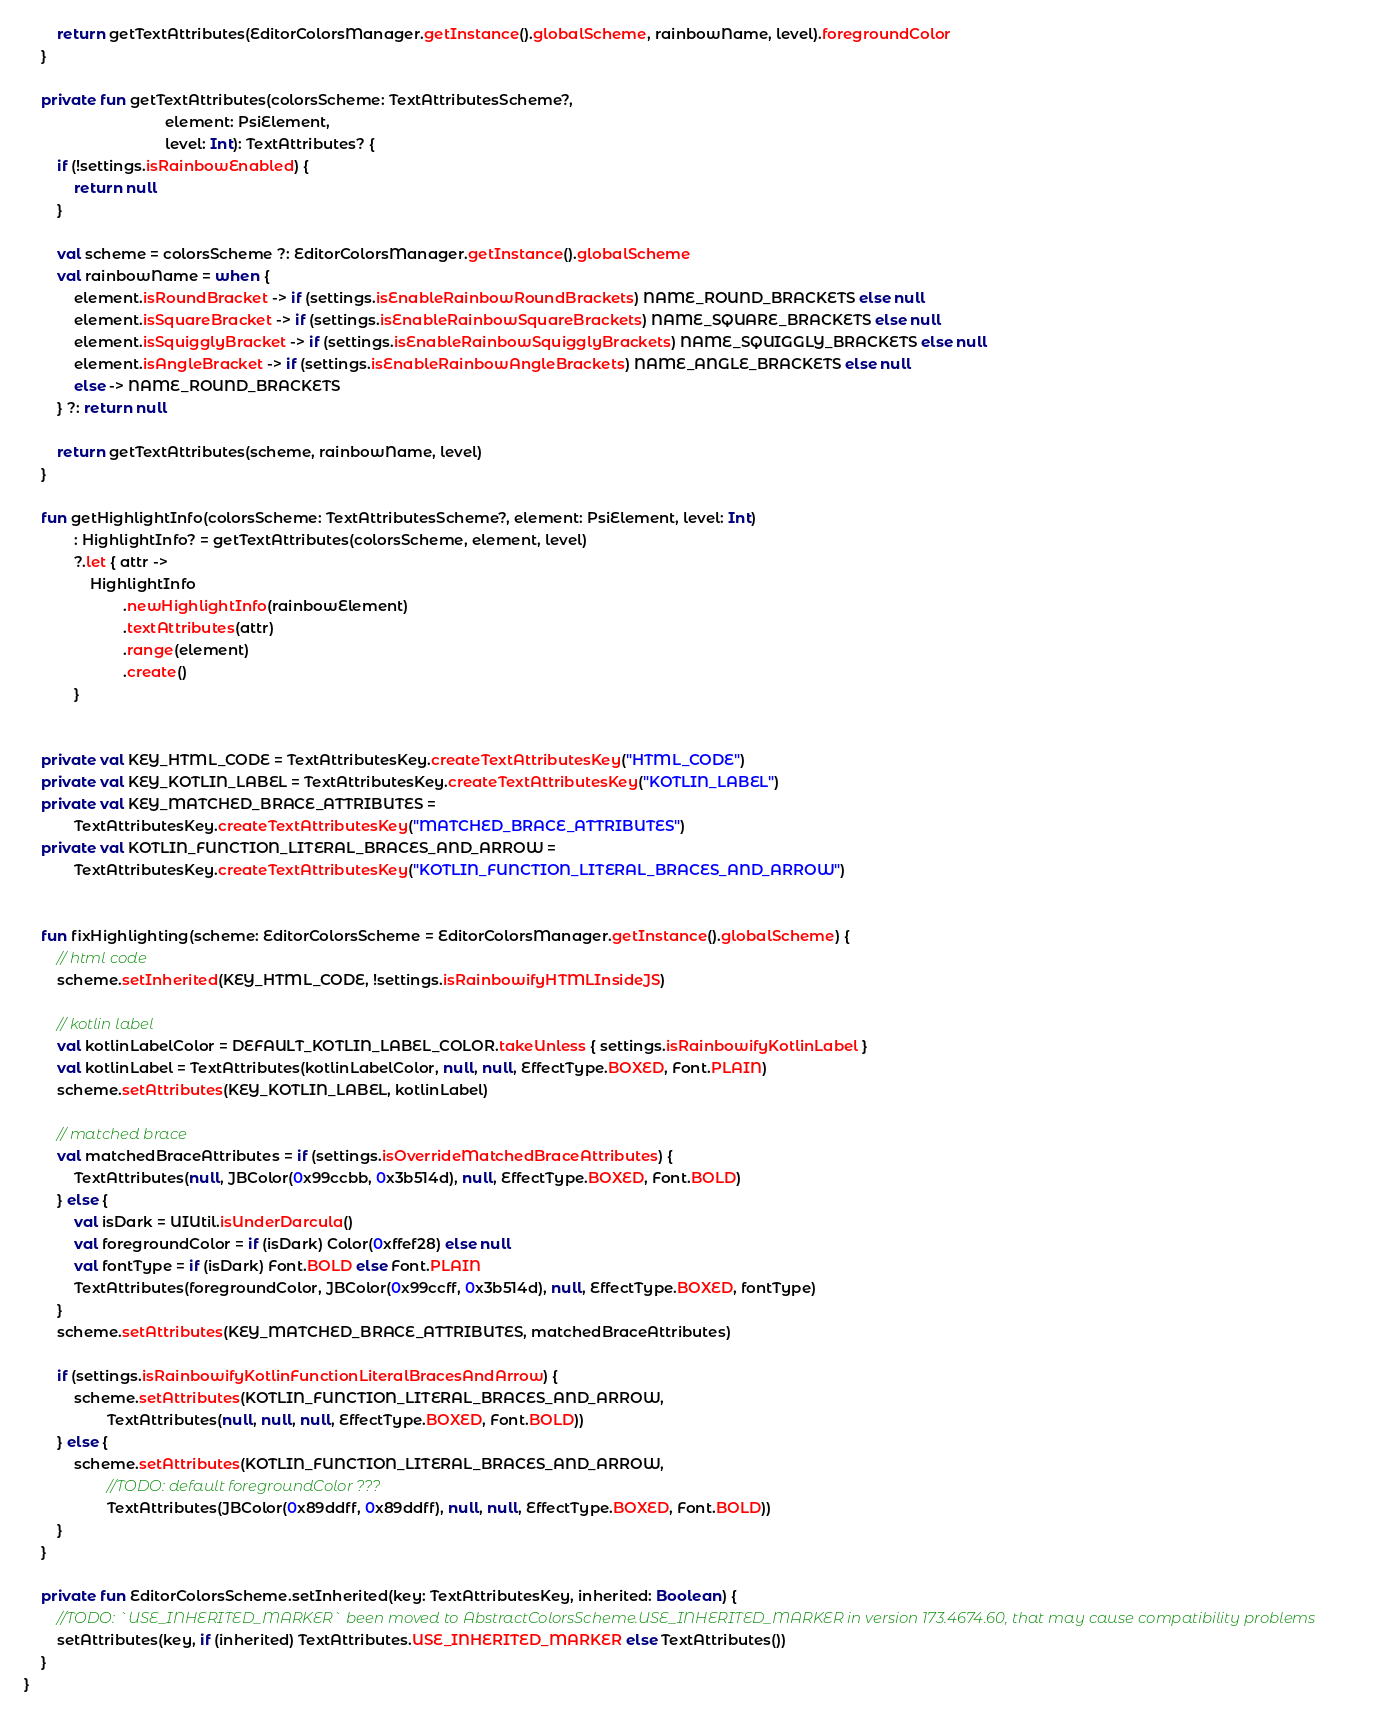Convert code to text. <code><loc_0><loc_0><loc_500><loc_500><_Kotlin_>        return getTextAttributes(EditorColorsManager.getInstance().globalScheme, rainbowName, level).foregroundColor
    }

    private fun getTextAttributes(colorsScheme: TextAttributesScheme?,
                                  element: PsiElement,
                                  level: Int): TextAttributes? {
        if (!settings.isRainbowEnabled) {
            return null
        }

        val scheme = colorsScheme ?: EditorColorsManager.getInstance().globalScheme
        val rainbowName = when {
            element.isRoundBracket -> if (settings.isEnableRainbowRoundBrackets) NAME_ROUND_BRACKETS else null
            element.isSquareBracket -> if (settings.isEnableRainbowSquareBrackets) NAME_SQUARE_BRACKETS else null
            element.isSquigglyBracket -> if (settings.isEnableRainbowSquigglyBrackets) NAME_SQUIGGLY_BRACKETS else null
            element.isAngleBracket -> if (settings.isEnableRainbowAngleBrackets) NAME_ANGLE_BRACKETS else null
            else -> NAME_ROUND_BRACKETS
        } ?: return null

        return getTextAttributes(scheme, rainbowName, level)
    }

    fun getHighlightInfo(colorsScheme: TextAttributesScheme?, element: PsiElement, level: Int)
            : HighlightInfo? = getTextAttributes(colorsScheme, element, level)
            ?.let { attr ->
                HighlightInfo
                        .newHighlightInfo(rainbowElement)
                        .textAttributes(attr)
                        .range(element)
                        .create()
            }


    private val KEY_HTML_CODE = TextAttributesKey.createTextAttributesKey("HTML_CODE")
    private val KEY_KOTLIN_LABEL = TextAttributesKey.createTextAttributesKey("KOTLIN_LABEL")
    private val KEY_MATCHED_BRACE_ATTRIBUTES =
            TextAttributesKey.createTextAttributesKey("MATCHED_BRACE_ATTRIBUTES")
    private val KOTLIN_FUNCTION_LITERAL_BRACES_AND_ARROW =
            TextAttributesKey.createTextAttributesKey("KOTLIN_FUNCTION_LITERAL_BRACES_AND_ARROW")


    fun fixHighlighting(scheme: EditorColorsScheme = EditorColorsManager.getInstance().globalScheme) {
        // html code
        scheme.setInherited(KEY_HTML_CODE, !settings.isRainbowifyHTMLInsideJS)

        // kotlin label
        val kotlinLabelColor = DEFAULT_KOTLIN_LABEL_COLOR.takeUnless { settings.isRainbowifyKotlinLabel }
        val kotlinLabel = TextAttributes(kotlinLabelColor, null, null, EffectType.BOXED, Font.PLAIN)
        scheme.setAttributes(KEY_KOTLIN_LABEL, kotlinLabel)

        // matched brace
        val matchedBraceAttributes = if (settings.isOverrideMatchedBraceAttributes) {
            TextAttributes(null, JBColor(0x99ccbb, 0x3b514d), null, EffectType.BOXED, Font.BOLD)
        } else {
            val isDark = UIUtil.isUnderDarcula()
            val foregroundColor = if (isDark) Color(0xffef28) else null
            val fontType = if (isDark) Font.BOLD else Font.PLAIN
            TextAttributes(foregroundColor, JBColor(0x99ccff, 0x3b514d), null, EffectType.BOXED, fontType)
        }
        scheme.setAttributes(KEY_MATCHED_BRACE_ATTRIBUTES, matchedBraceAttributes)

        if (settings.isRainbowifyKotlinFunctionLiteralBracesAndArrow) {
            scheme.setAttributes(KOTLIN_FUNCTION_LITERAL_BRACES_AND_ARROW,
                    TextAttributes(null, null, null, EffectType.BOXED, Font.BOLD))
        } else {
            scheme.setAttributes(KOTLIN_FUNCTION_LITERAL_BRACES_AND_ARROW,
                    //TODO: default foregroundColor ???
                    TextAttributes(JBColor(0x89ddff, 0x89ddff), null, null, EffectType.BOXED, Font.BOLD))
        }
    }

    private fun EditorColorsScheme.setInherited(key: TextAttributesKey, inherited: Boolean) {
        //TODO: `USE_INHERITED_MARKER` been moved to AbstractColorsScheme.USE_INHERITED_MARKER in version 173.4674.60, that may cause compatibility problems
        setAttributes(key, if (inherited) TextAttributes.USE_INHERITED_MARKER else TextAttributes())
    }
}
</code> 